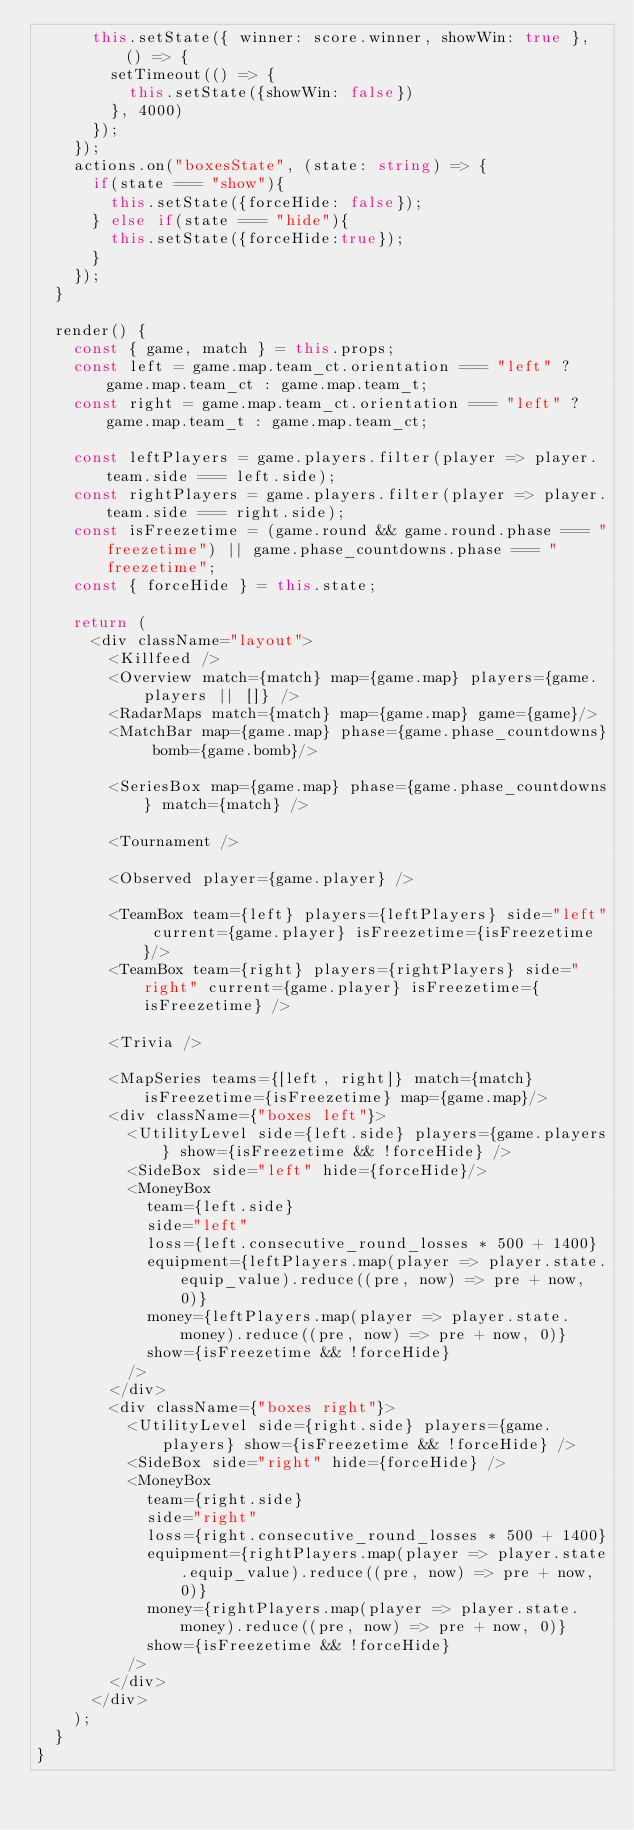<code> <loc_0><loc_0><loc_500><loc_500><_TypeScript_>      this.setState({ winner: score.winner, showWin: true }, () => {
        setTimeout(() => {
          this.setState({showWin: false})
        }, 4000)
      });
    });
    actions.on("boxesState", (state: string) => {
      if(state === "show"){
        this.setState({forceHide: false});
      } else if(state === "hide"){
        this.setState({forceHide:true});
      }
    });
  }

  render() {
    const { game, match } = this.props;
    const left = game.map.team_ct.orientation === "left" ? game.map.team_ct : game.map.team_t;
    const right = game.map.team_ct.orientation === "left" ? game.map.team_t : game.map.team_ct;

    const leftPlayers = game.players.filter(player => player.team.side === left.side);
    const rightPlayers = game.players.filter(player => player.team.side === right.side);
    const isFreezetime = (game.round && game.round.phase === "freezetime") || game.phase_countdowns.phase === "freezetime";
    const { forceHide } = this.state;

    return (
      <div className="layout">
        <Killfeed />
        <Overview match={match} map={game.map} players={game.players || []} />
        <RadarMaps match={match} map={game.map} game={game}/>
        <MatchBar map={game.map} phase={game.phase_countdowns} bomb={game.bomb}/>

        <SeriesBox map={game.map} phase={game.phase_countdowns} match={match} />

        <Tournament />

        <Observed player={game.player} />

        <TeamBox team={left} players={leftPlayers} side="left" current={game.player} isFreezetime={isFreezetime}/>
        <TeamBox team={right} players={rightPlayers} side="right" current={game.player} isFreezetime={isFreezetime} />

        <Trivia />
        
        <MapSeries teams={[left, right]} match={match} isFreezetime={isFreezetime} map={game.map}/>
        <div className={"boxes left"}>
          <UtilityLevel side={left.side} players={game.players} show={isFreezetime && !forceHide} />
          <SideBox side="left" hide={forceHide}/>
          <MoneyBox
            team={left.side}
            side="left"
            loss={left.consecutive_round_losses * 500 + 1400}
            equipment={leftPlayers.map(player => player.state.equip_value).reduce((pre, now) => pre + now, 0)}
            money={leftPlayers.map(player => player.state.money).reduce((pre, now) => pre + now, 0)}
            show={isFreezetime && !forceHide}
          />
        </div>
        <div className={"boxes right"}>
          <UtilityLevel side={right.side} players={game.players} show={isFreezetime && !forceHide} />
          <SideBox side="right" hide={forceHide} />
          <MoneyBox
            team={right.side}
            side="right"
            loss={right.consecutive_round_losses * 500 + 1400}
            equipment={rightPlayers.map(player => player.state.equip_value).reduce((pre, now) => pre + now, 0)}
            money={rightPlayers.map(player => player.state.money).reduce((pre, now) => pre + now, 0)}
            show={isFreezetime && !forceHide}
          />
        </div>
      </div>
    );
  }
}
</code> 